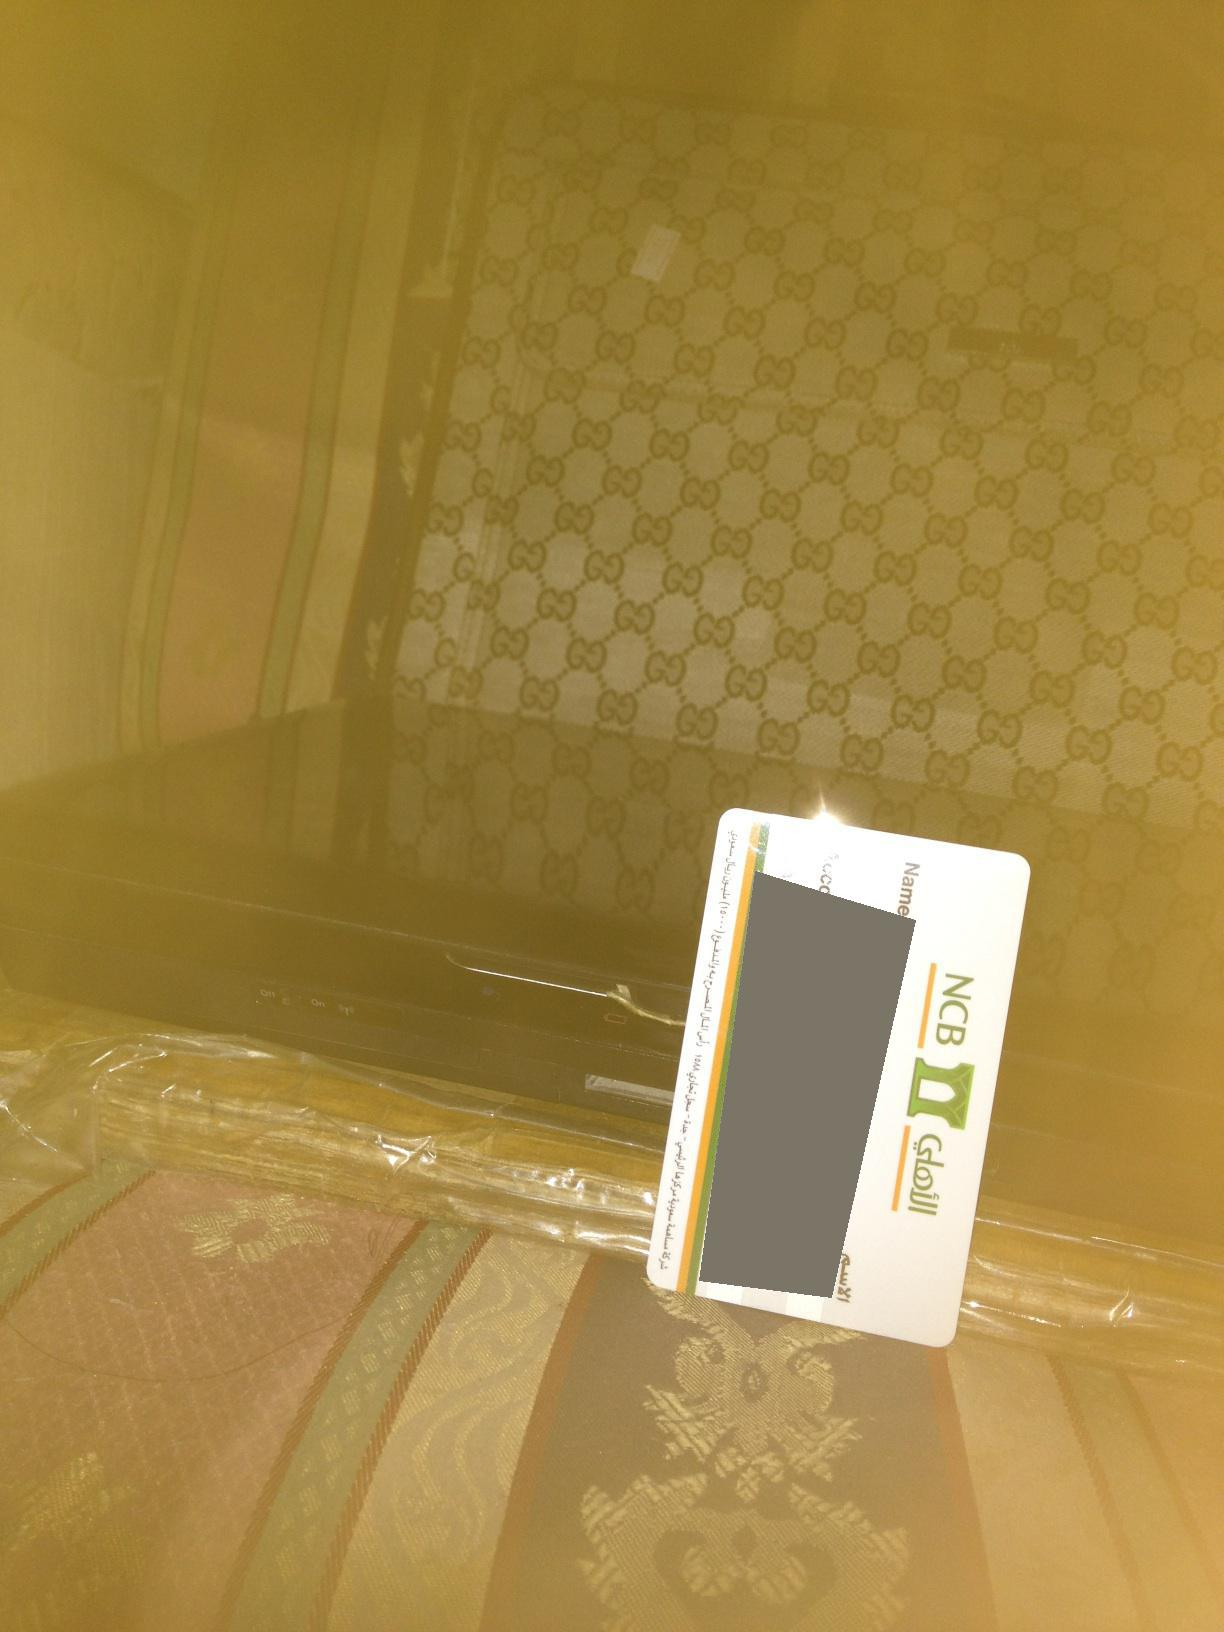Describe the setting and the items in detail. The image appears to have been taken in a room with a patterned fabric background. There is a suitcase with a recognizable logo design, likely indicating a luxury brand. A credit card, issued by 'NCB', is placed on top of the suitcase. Below the suitcase, there is an electronic device covered in transparent plastic, suggesting it might be new or being protected. The overall setting gives an impression of care and a slightly luxurious environment.  Can you imagine a backstory for this scene? Imagine someone just returned from a luxury shopping spree. The suitcase, stylish and branded, was purchased from a high-end store. The credit card, placed on top for a moment, was used to make several lavish purchases, including the electronic device partially visible in the picture. This device could be a new piece of audio or video equipment, meticulously wrapped to avoid any damage. The scenario suggests a setting of opulence and care, where the individual values and secures their high-end acquisitions. 